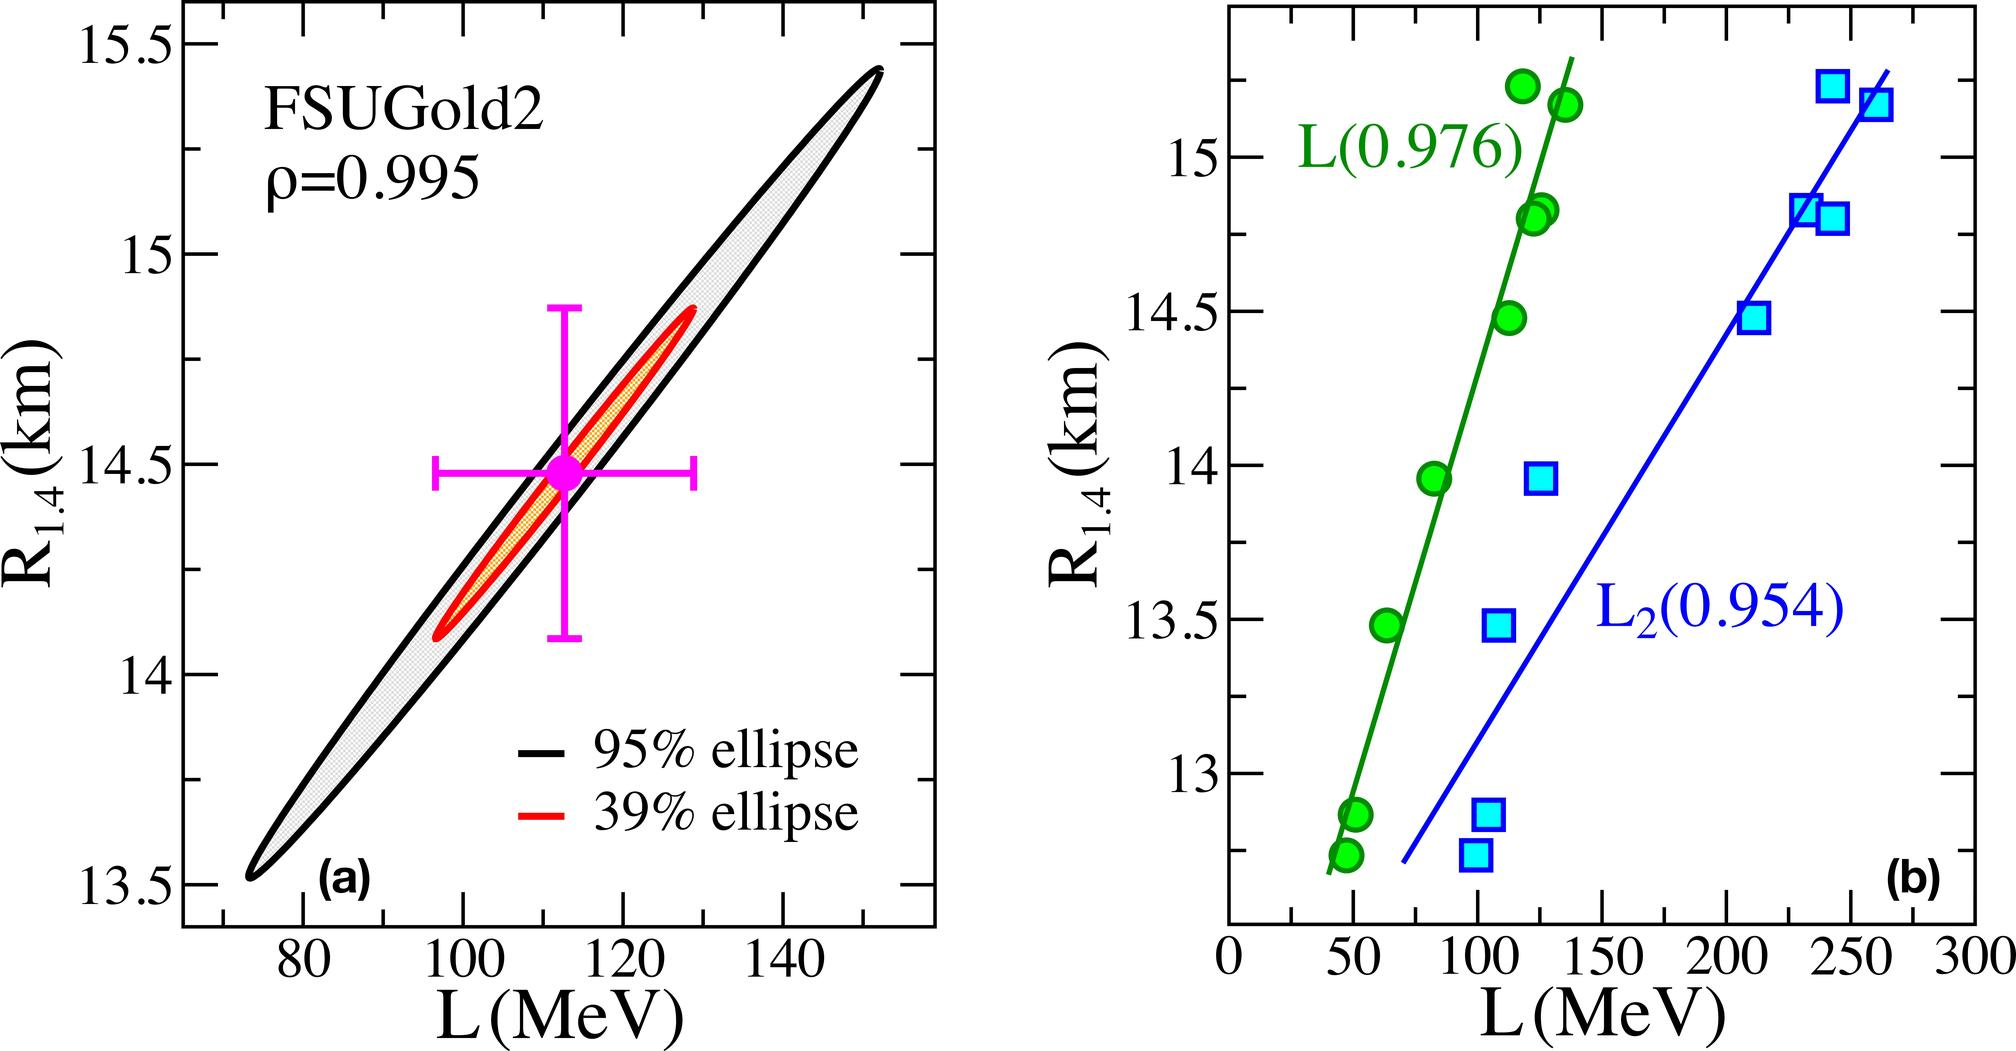What does the 95% ellipse on the FSUGold2 graph represent? The 95% ellipse depicted on the FSUGold2 graph in figure (a) represents the confidence region within which the true values of L and R_1.4 are expected to fall with 95% probability. This ellipse provides a visual understanding of the uncertainty associated with the predictions of the FSUGold2 model, allowing researchers to estimate the precision of their measurements and model's predictions. 